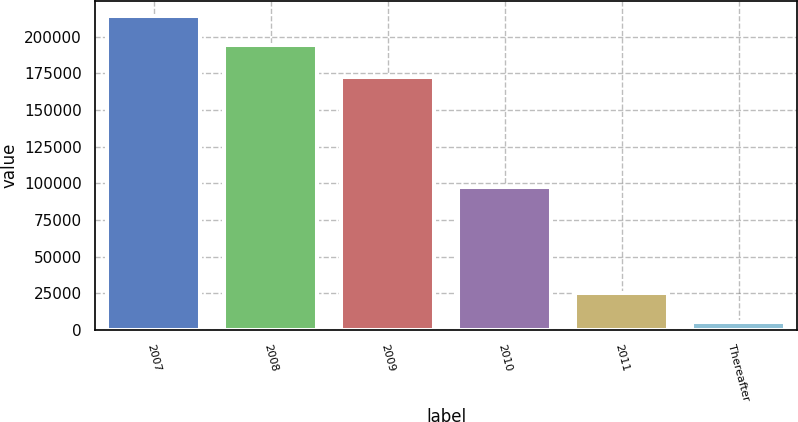<chart> <loc_0><loc_0><loc_500><loc_500><bar_chart><fcel>2007<fcel>2008<fcel>2009<fcel>2010<fcel>2011<fcel>Thereafter<nl><fcel>213730<fcel>194018<fcel>172708<fcel>97176<fcel>25137.9<fcel>5426<nl></chart> 